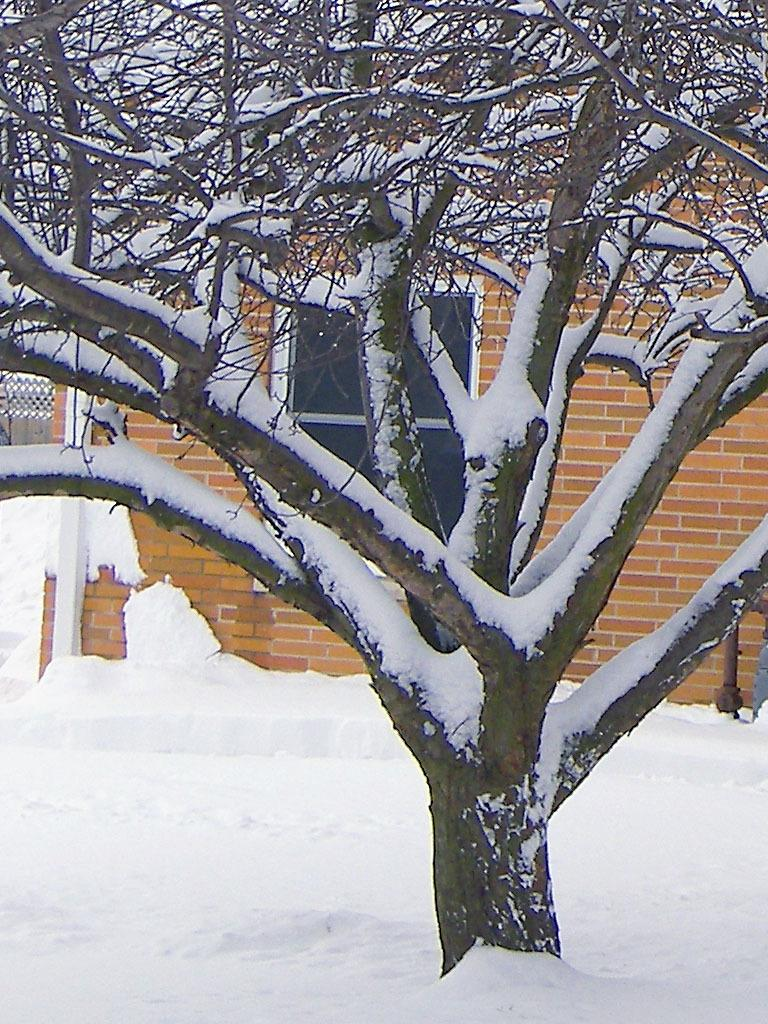What is the condition of the road in the image? The road is covered with snow in the image. What else is covered with snow in the image? There is a tree covered with snow in the image. What can be seen in the background of the image? There is a brick wall and glass windows visible in the background of the image. Can you see any fairies flying around the tree in the image? There are no fairies present in the image; it only shows a snow-covered tree and road. Is there a gun visible in the image? There is no gun present in the image. 